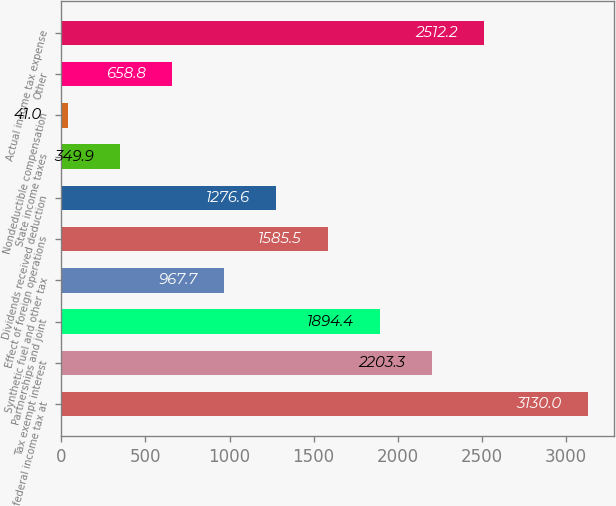Convert chart. <chart><loc_0><loc_0><loc_500><loc_500><bar_chart><fcel>US federal income tax at<fcel>Tax exempt interest<fcel>Partnerships and joint<fcel>Synthetic fuel and other tax<fcel>Effect of foreign operations<fcel>Dividends received deduction<fcel>State income taxes<fcel>Nondeductible compensation<fcel>Other<fcel>Actual income tax expense<nl><fcel>3130<fcel>2203.3<fcel>1894.4<fcel>967.7<fcel>1585.5<fcel>1276.6<fcel>349.9<fcel>41<fcel>658.8<fcel>2512.2<nl></chart> 